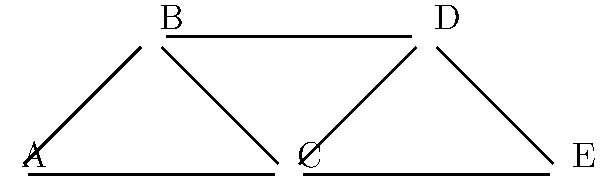In the co-authorship network shown above, which researcher has the highest degree centrality in the field of gender and sexuality studies in sociology? To determine the researcher with the highest degree centrality, we need to follow these steps:

1. Understand degree centrality: It is the number of direct connections a node has in a network.

2. Count connections for each researcher:
   A: 2 connections (B and C)
   B: 3 connections (A, C, and D)
   C: 4 connections (A, B, D, and E)
   D: 3 connections (B, C, and E)
   E: 2 connections (C and D)

3. Compare the counts:
   C has the highest number of connections with 4.

4. Interpret the result: Researcher C has collaborated with the most other researchers in this network, indicating they have the highest degree centrality.

This suggests that Researcher C is likely a key figure in gender and sexuality studies within sociology, with extensive collaborative relationships in the field.
Answer: C 